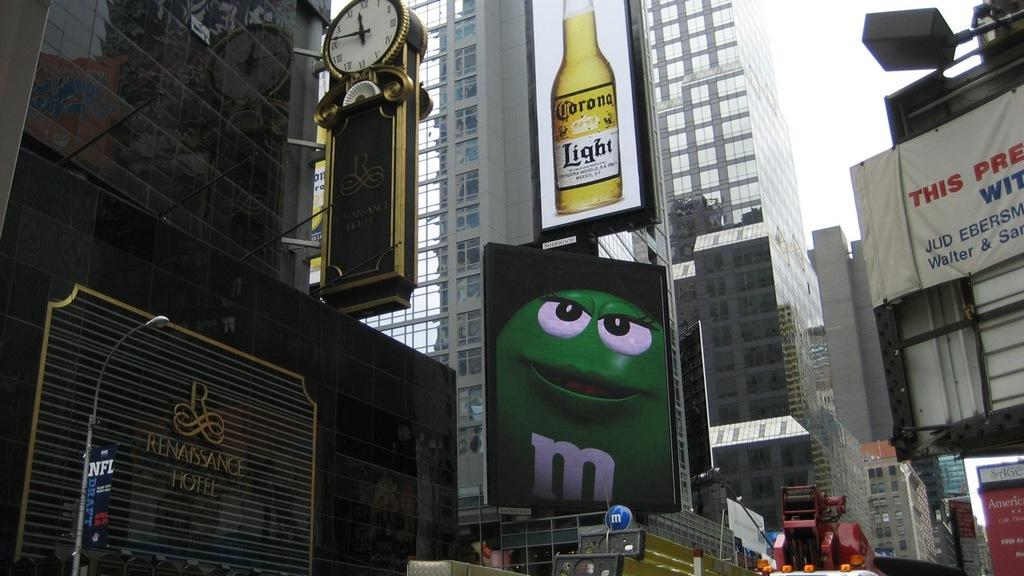<image>
Present a compact description of the photo's key features. An urban city with a large advert for Corona Light 